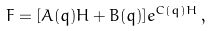<formula> <loc_0><loc_0><loc_500><loc_500>F = [ A ( q ) H + B ( q ) ] e ^ { C ( q ) H } \, ,</formula> 